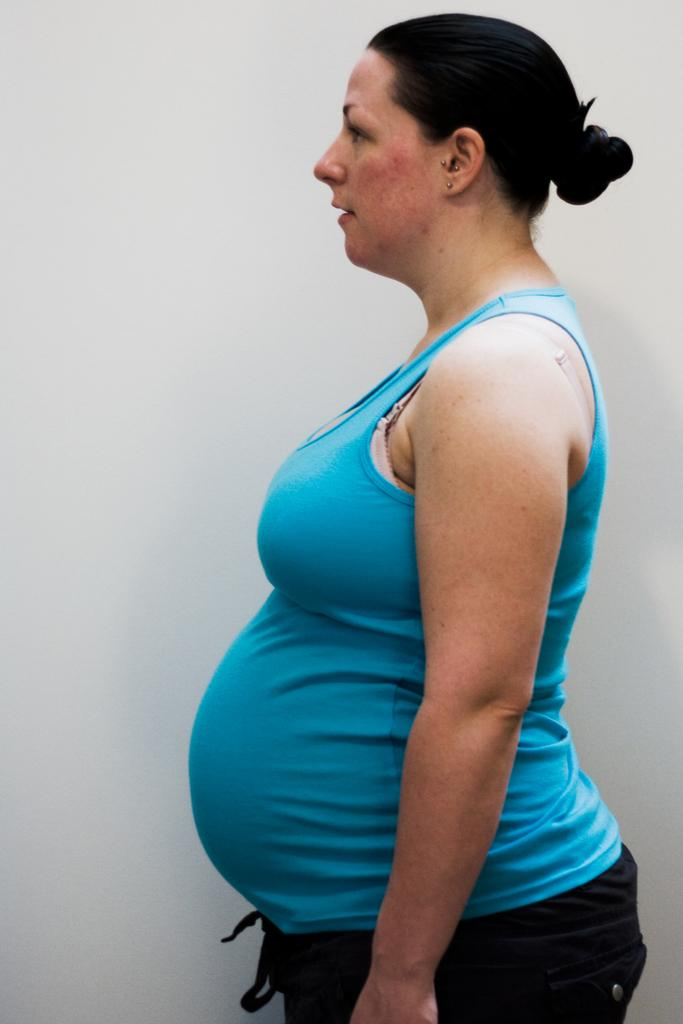Who is the main subject in the image? There is a woman in the image. What is the woman doing in the image? The woman is standing. What color is the top that the woman is wearing? The woman is wearing a blue top. What color is the background of the image? The background of the image is white. What type of book is the woman holding in the image? There is no book present in the image; the woman is not holding anything. 